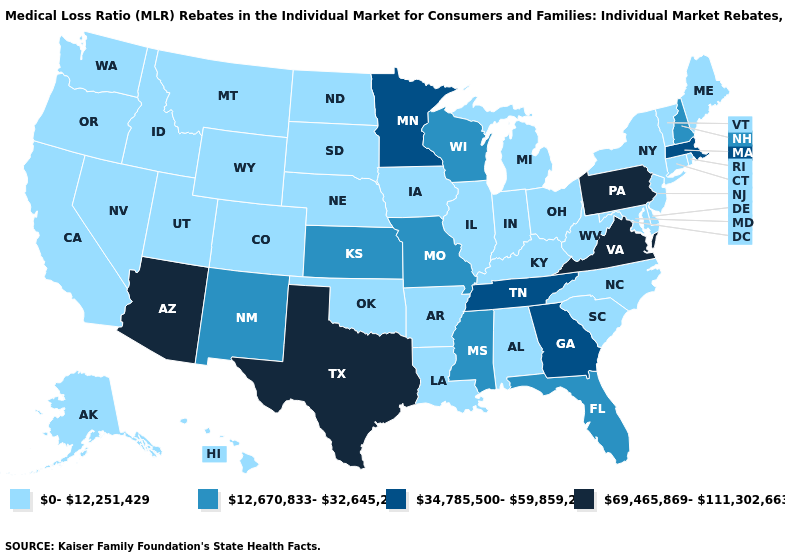Name the states that have a value in the range 0-12,251,429?
Concise answer only. Alabama, Alaska, Arkansas, California, Colorado, Connecticut, Delaware, Hawaii, Idaho, Illinois, Indiana, Iowa, Kentucky, Louisiana, Maine, Maryland, Michigan, Montana, Nebraska, Nevada, New Jersey, New York, North Carolina, North Dakota, Ohio, Oklahoma, Oregon, Rhode Island, South Carolina, South Dakota, Utah, Vermont, Washington, West Virginia, Wyoming. What is the value of Louisiana?
Answer briefly. 0-12,251,429. Is the legend a continuous bar?
Give a very brief answer. No. What is the value of Utah?
Write a very short answer. 0-12,251,429. What is the lowest value in the USA?
Write a very short answer. 0-12,251,429. Does Oregon have the lowest value in the USA?
Answer briefly. Yes. Name the states that have a value in the range 0-12,251,429?
Be succinct. Alabama, Alaska, Arkansas, California, Colorado, Connecticut, Delaware, Hawaii, Idaho, Illinois, Indiana, Iowa, Kentucky, Louisiana, Maine, Maryland, Michigan, Montana, Nebraska, Nevada, New Jersey, New York, North Carolina, North Dakota, Ohio, Oklahoma, Oregon, Rhode Island, South Carolina, South Dakota, Utah, Vermont, Washington, West Virginia, Wyoming. Among the states that border New York , does Connecticut have the lowest value?
Quick response, please. Yes. What is the value of Utah?
Be succinct. 0-12,251,429. Name the states that have a value in the range 69,465,869-111,302,663?
Give a very brief answer. Arizona, Pennsylvania, Texas, Virginia. What is the value of South Carolina?
Answer briefly. 0-12,251,429. Name the states that have a value in the range 69,465,869-111,302,663?
Keep it brief. Arizona, Pennsylvania, Texas, Virginia. What is the value of New Jersey?
Give a very brief answer. 0-12,251,429. What is the highest value in the USA?
Short answer required. 69,465,869-111,302,663. Which states have the highest value in the USA?
Quick response, please. Arizona, Pennsylvania, Texas, Virginia. 